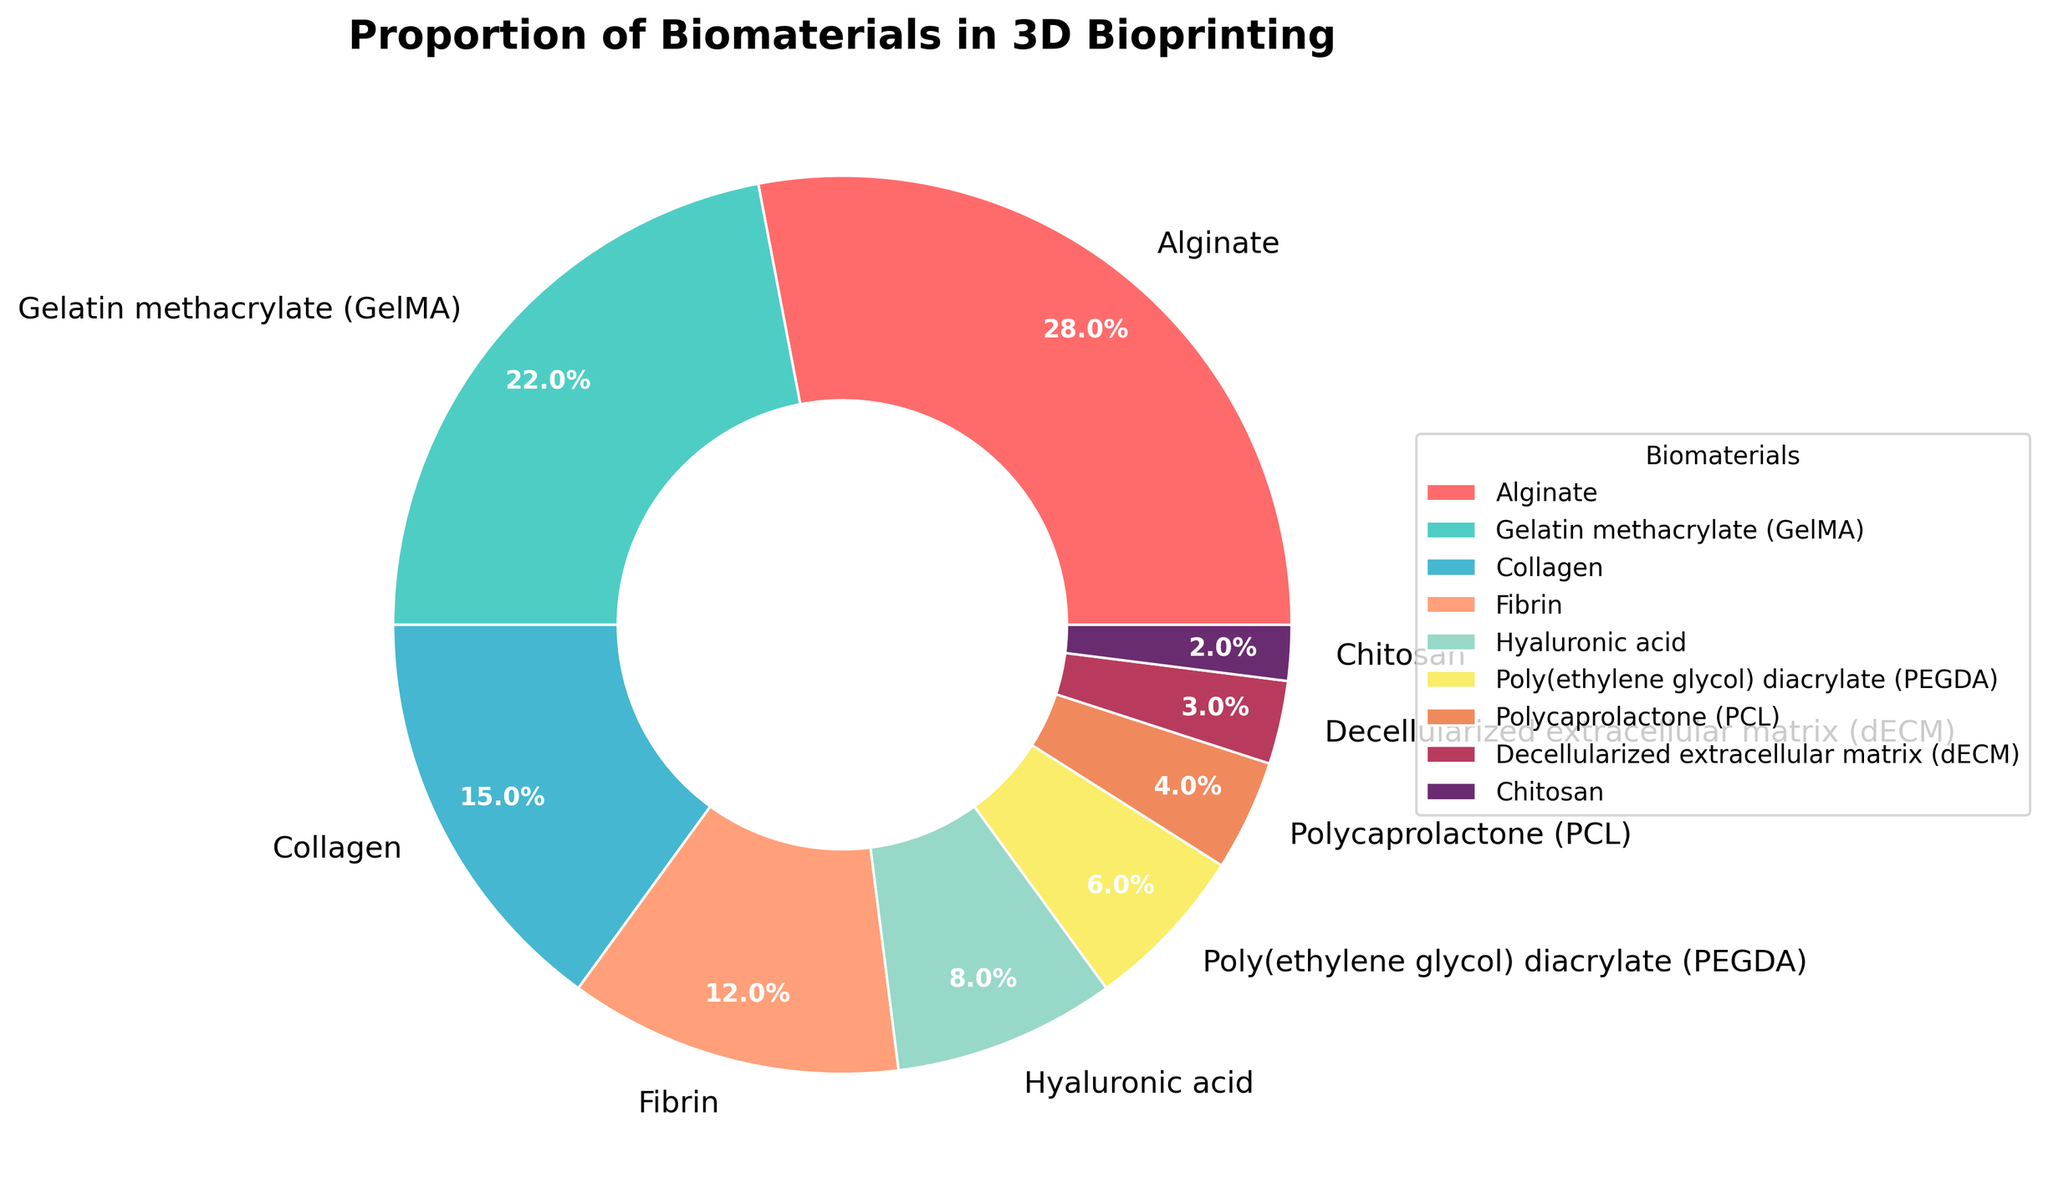What is the percentage of Alginate used in 3D bioprinting? The pie chart visually shows a slice labeled "Alginate" with a percentage indicated next to it.
Answer: 28% Which biomaterial has the smallest proportion in 3D bioprinting? The pie chart shows the smallest slice labeled "Chitosan" with the percentage next to it.
Answer: Chitosan How much larger, in percentage points, is the use of Alginate compared to Collagen? To determine the difference, subtract the percentage of Collagen from Alginate (28% - 15%).
Answer: 13 What is the combined percentage of Gelatin methacrylate (GelMA) and Poly(ethylene glycol) diacrylate (PEGDA)? Add the percentages of GelMA (22%) and PEGDA (6%) together (22% + 6%).
Answer: 28% Which has a higher proportion: Fibrin or Hyaluronic acid? Compare the slices labeled "Fibrin" and "Hyaluronic acid" to see which one is larger. Fibrin is 12%, while Hyaluronic acid is 8%.
Answer: Fibrin What proportion of the biomaterials used in 3D bioprinting are synthetic materials? Identify synthetic biomaterials: Poly(ethylene glycol) diacrylate (PEGDA) (6%) and Polycaprolactone (PCL) (4%), then sum their percentages (6% + 4%).
Answer: 10% Compare the use of Gelatin methacrylate (GelMA) and Decellularized extracellular matrix (dECM) in 3D bioprinting. Which one is used more often and by what percentage? Compare the percentages: GelMA is 22% and dECM is 3%. Subtract the smaller percentage from the larger (22% - 3%).
Answer: GelMA by 19% How does the proportion of Collagen used compare to the combination of Chitosan and Decellularized extracellular matrix (dECM)? First, find the combined percentage of Chitosan and dECM (2% + 3% = 5%). Then compare it to Collagen (15%).
Answer: Collagen is 10% more What is the overall percentage of natural biomaterials used? Add the percentages of Alginate (28%), Gelatin methacrylate (GelMA) (22%), Collagen (15%), Fibrin (12%), Hyaluronic acid (8%), and Decellularized extracellular matrix (dECM) (3%) (28% + 22% + 15% + 12% + 8% + 3%).
Answer: 88% Which color represents the biomaterial with the highest percentage, and what is the corresponding biomaterial? Identify the color of the largest slice, which shows Alginate (28%), represented by a shade of red in the pie chart.
Answer: Red, Alginate 